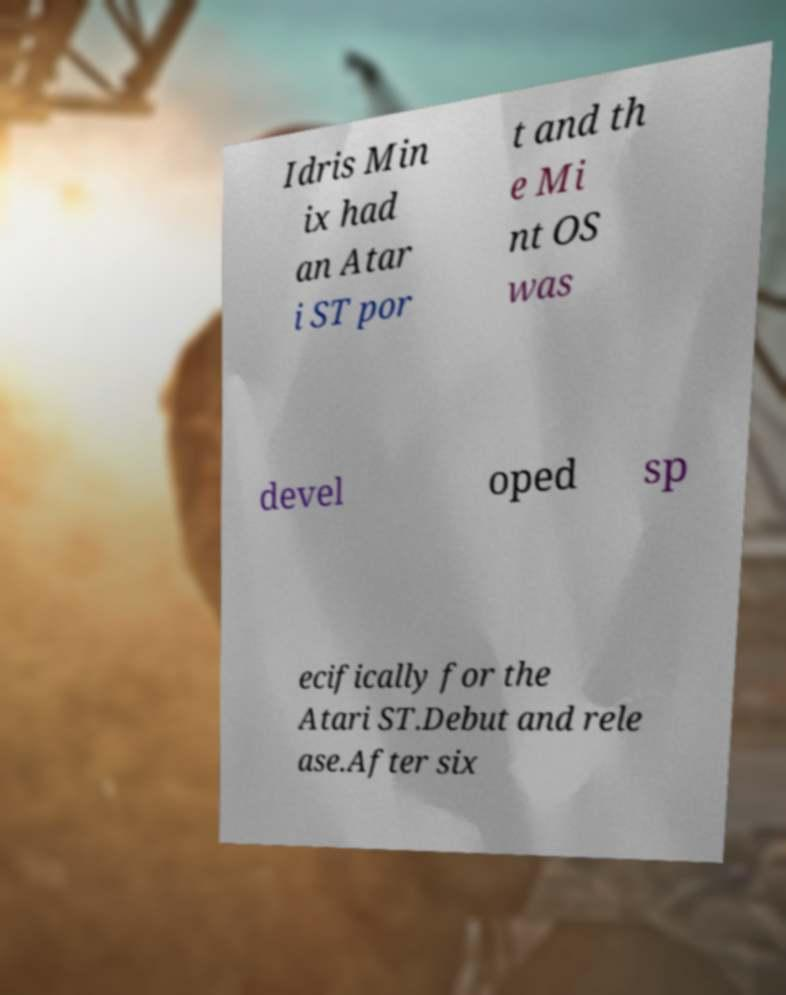Can you accurately transcribe the text from the provided image for me? Idris Min ix had an Atar i ST por t and th e Mi nt OS was devel oped sp ecifically for the Atari ST.Debut and rele ase.After six 